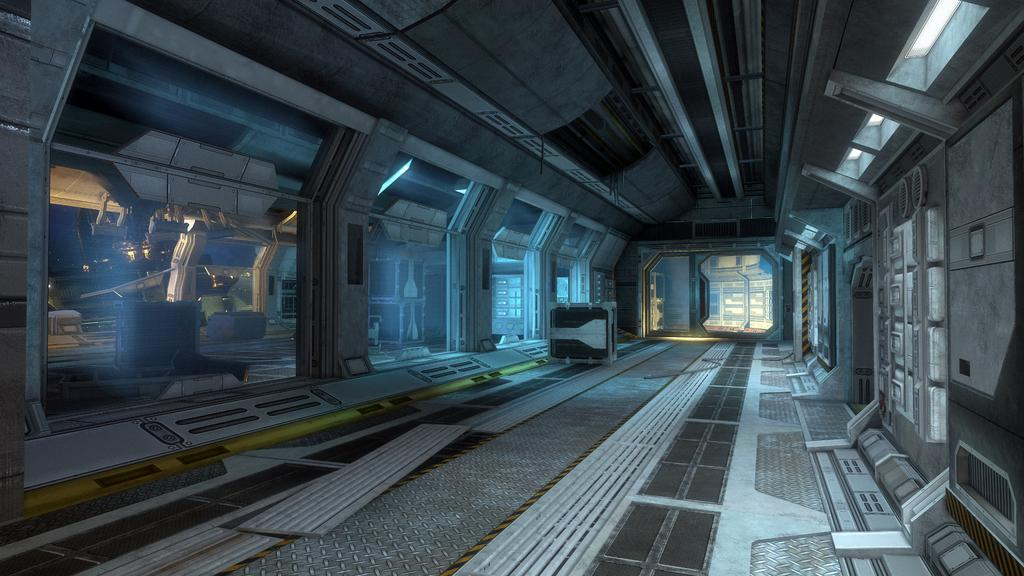What type of location is depicted in the image? The image is of an inside part. What can be seen on the left side of the image? There are glass walls on the left side of the image. What effect do the cherries have on the boy in the image? There are no cherries or boy present in the image, so it is not possible to determine any effect. 